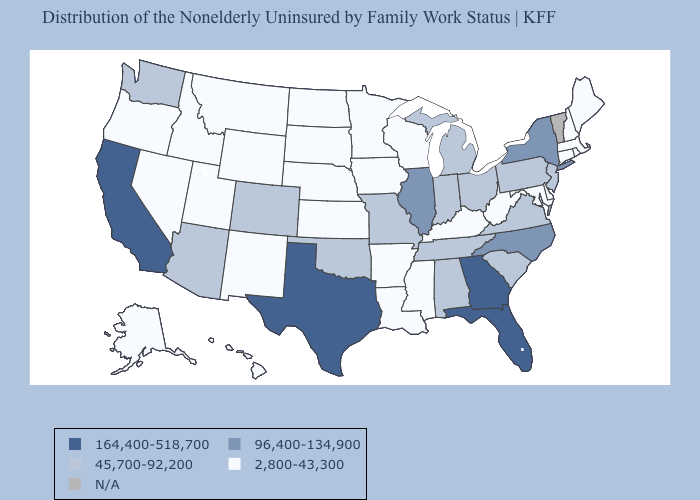Name the states that have a value in the range 164,400-518,700?
Short answer required. California, Florida, Georgia, Texas. What is the value of Kentucky?
Quick response, please. 2,800-43,300. Does Maine have the highest value in the USA?
Answer briefly. No. What is the highest value in states that border South Dakota?
Quick response, please. 2,800-43,300. Does Oregon have the highest value in the West?
Answer briefly. No. Which states have the lowest value in the Northeast?
Give a very brief answer. Connecticut, Maine, Massachusetts, New Hampshire, Rhode Island. What is the value of Missouri?
Quick response, please. 45,700-92,200. Which states have the lowest value in the West?
Answer briefly. Alaska, Hawaii, Idaho, Montana, Nevada, New Mexico, Oregon, Utah, Wyoming. What is the lowest value in the USA?
Write a very short answer. 2,800-43,300. What is the value of Louisiana?
Keep it brief. 2,800-43,300. What is the value of North Dakota?
Give a very brief answer. 2,800-43,300. What is the lowest value in the Northeast?
Answer briefly. 2,800-43,300. How many symbols are there in the legend?
Answer briefly. 5. Does Texas have the highest value in the South?
Keep it brief. Yes. 